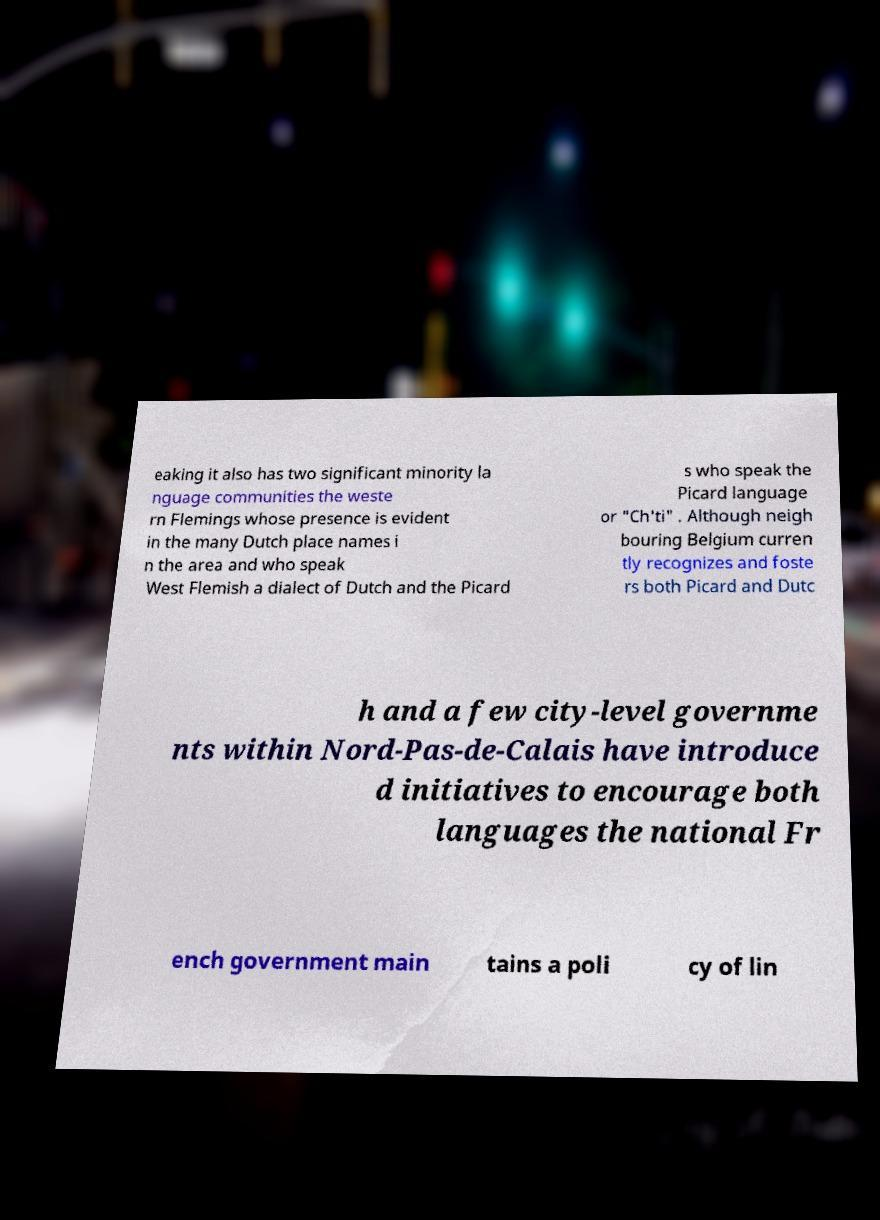Could you assist in decoding the text presented in this image and type it out clearly? eaking it also has two significant minority la nguage communities the weste rn Flemings whose presence is evident in the many Dutch place names i n the area and who speak West Flemish a dialect of Dutch and the Picard s who speak the Picard language or "Ch'ti" . Although neigh bouring Belgium curren tly recognizes and foste rs both Picard and Dutc h and a few city-level governme nts within Nord-Pas-de-Calais have introduce d initiatives to encourage both languages the national Fr ench government main tains a poli cy of lin 